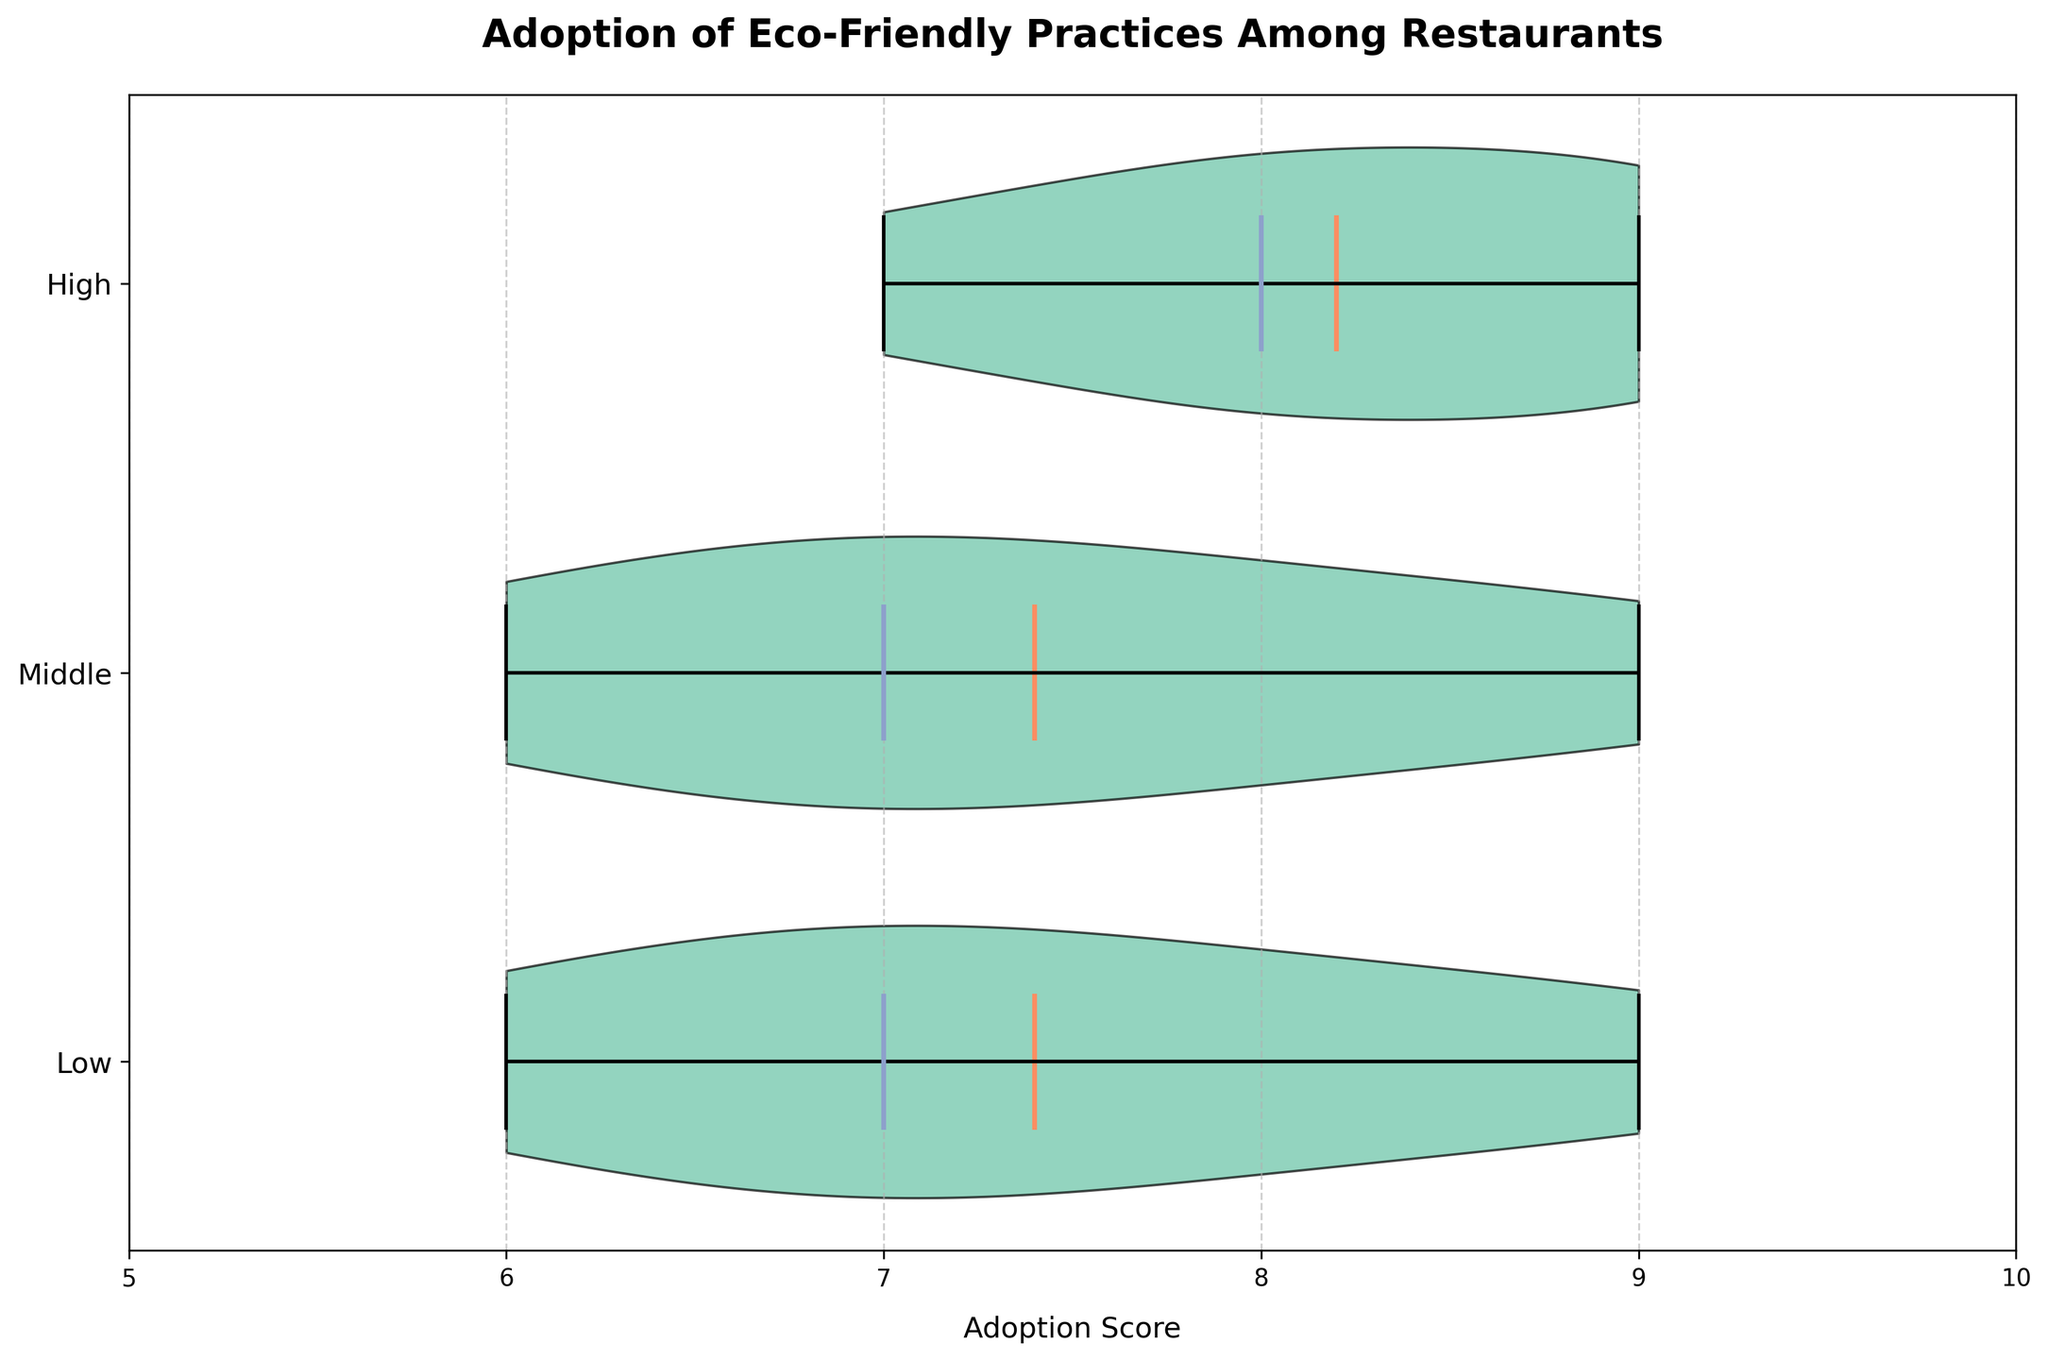What is the title of the chart? The title of the chart is written at the top in bold and larger font size. It provides a summary of what the chart displays.
Answer: Adoption of Eco-Friendly Practices Among Restaurants What does the horizontal axis represent? The horizontal axis in the plot is labeled, indicating what it measures. This helps identify the key variable.
Answer: Adoption Score What is the range of the adoption scores shown on the horizontal axis? The horizontal axis has tick marks and labels that show the minimum and maximum values. The range covers the extent of scores displayed.
Answer: 5 to 10 Which income level has the highest mean adoption score? The chart indicates the mean values of adoption scores with a different colored line. By identifying the mean lines for each income level, you can determine the one with the highest mean.
Answer: High What is the median adoption score for the middle income level? Median values in a violin plot are often marked differently, typically with a line or a dot. By locating this for the middle income group, the value can be obtained.
Answer: 7 Which income level shows the widest distribution of adoption scores? The width of the violin plot areas represents the distribution of scores. The group whose violin plot is the widest indicates the broadest score range.
Answer: Low Between which two income levels is the mean adoption score the same? The horizontal lines indicating the mean for each group should be compared to see which groups have their mean lines on the same vertical level.
Answer: Low and Middle Do any income levels have overlapping adoption scores? By examining the overlap of the violin plots, we can determine if any of the input levels share common adoption score ranges.
Answer: Yes What color represents the body of the violin plots? The visual appearance of the violin plot's body is described, including color. This is crucial for visual understanding and identification.
Answer: Light green How do the adoption scores for the high income level compare to those for the low income level? By comparing the violin plots for both high and low income groups, an analysis of how their scores differ or overlap can be made.
Answer: Generally higher 